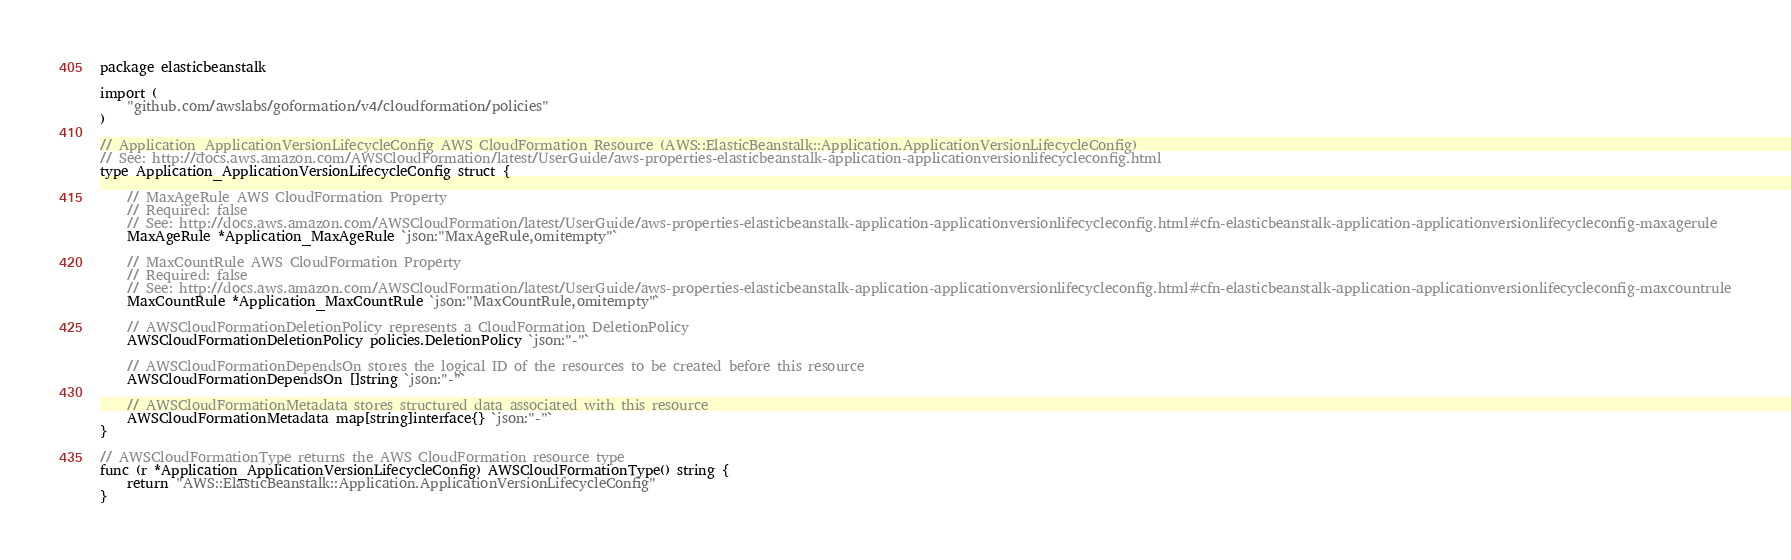<code> <loc_0><loc_0><loc_500><loc_500><_Go_>package elasticbeanstalk

import (
	"github.com/awslabs/goformation/v4/cloudformation/policies"
)

// Application_ApplicationVersionLifecycleConfig AWS CloudFormation Resource (AWS::ElasticBeanstalk::Application.ApplicationVersionLifecycleConfig)
// See: http://docs.aws.amazon.com/AWSCloudFormation/latest/UserGuide/aws-properties-elasticbeanstalk-application-applicationversionlifecycleconfig.html
type Application_ApplicationVersionLifecycleConfig struct {

	// MaxAgeRule AWS CloudFormation Property
	// Required: false
	// See: http://docs.aws.amazon.com/AWSCloudFormation/latest/UserGuide/aws-properties-elasticbeanstalk-application-applicationversionlifecycleconfig.html#cfn-elasticbeanstalk-application-applicationversionlifecycleconfig-maxagerule
	MaxAgeRule *Application_MaxAgeRule `json:"MaxAgeRule,omitempty"`

	// MaxCountRule AWS CloudFormation Property
	// Required: false
	// See: http://docs.aws.amazon.com/AWSCloudFormation/latest/UserGuide/aws-properties-elasticbeanstalk-application-applicationversionlifecycleconfig.html#cfn-elasticbeanstalk-application-applicationversionlifecycleconfig-maxcountrule
	MaxCountRule *Application_MaxCountRule `json:"MaxCountRule,omitempty"`

	// AWSCloudFormationDeletionPolicy represents a CloudFormation DeletionPolicy
	AWSCloudFormationDeletionPolicy policies.DeletionPolicy `json:"-"`

	// AWSCloudFormationDependsOn stores the logical ID of the resources to be created before this resource
	AWSCloudFormationDependsOn []string `json:"-"`

	// AWSCloudFormationMetadata stores structured data associated with this resource
	AWSCloudFormationMetadata map[string]interface{} `json:"-"`
}

// AWSCloudFormationType returns the AWS CloudFormation resource type
func (r *Application_ApplicationVersionLifecycleConfig) AWSCloudFormationType() string {
	return "AWS::ElasticBeanstalk::Application.ApplicationVersionLifecycleConfig"
}
</code> 